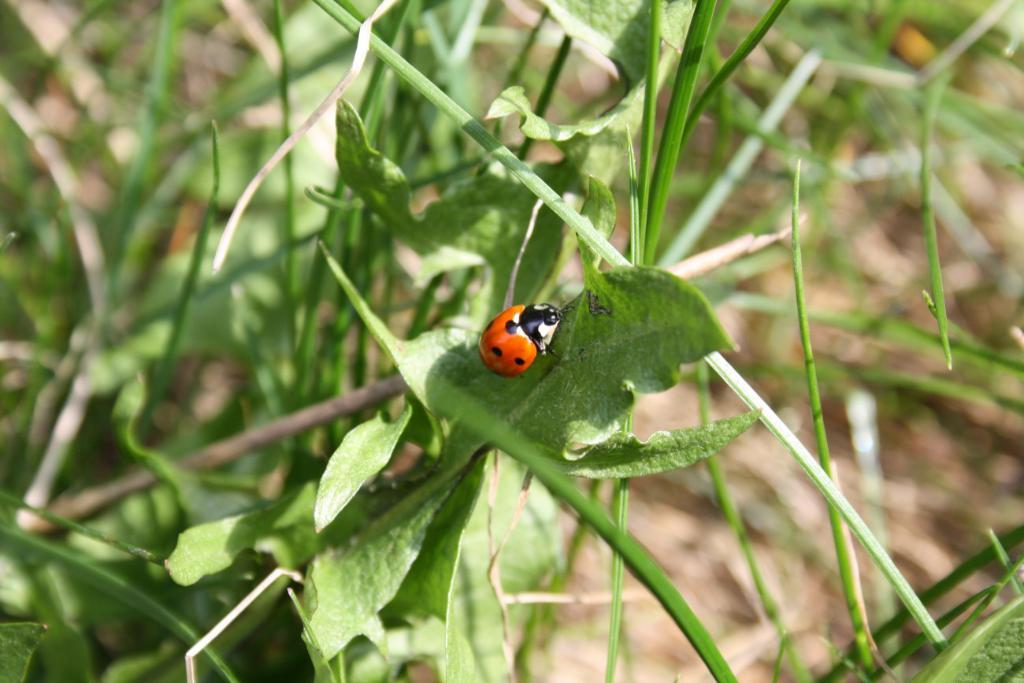What type of living organism can be seen in the picture? There is an insect in the picture. What other elements are present in the image besides the insect? There are plants and the ground visible in the picture. Can you describe the background of the image? The background of the image is blurred. What disease is the insect spreading in the image? There is no indication in the image that the insect is spreading any disease. 